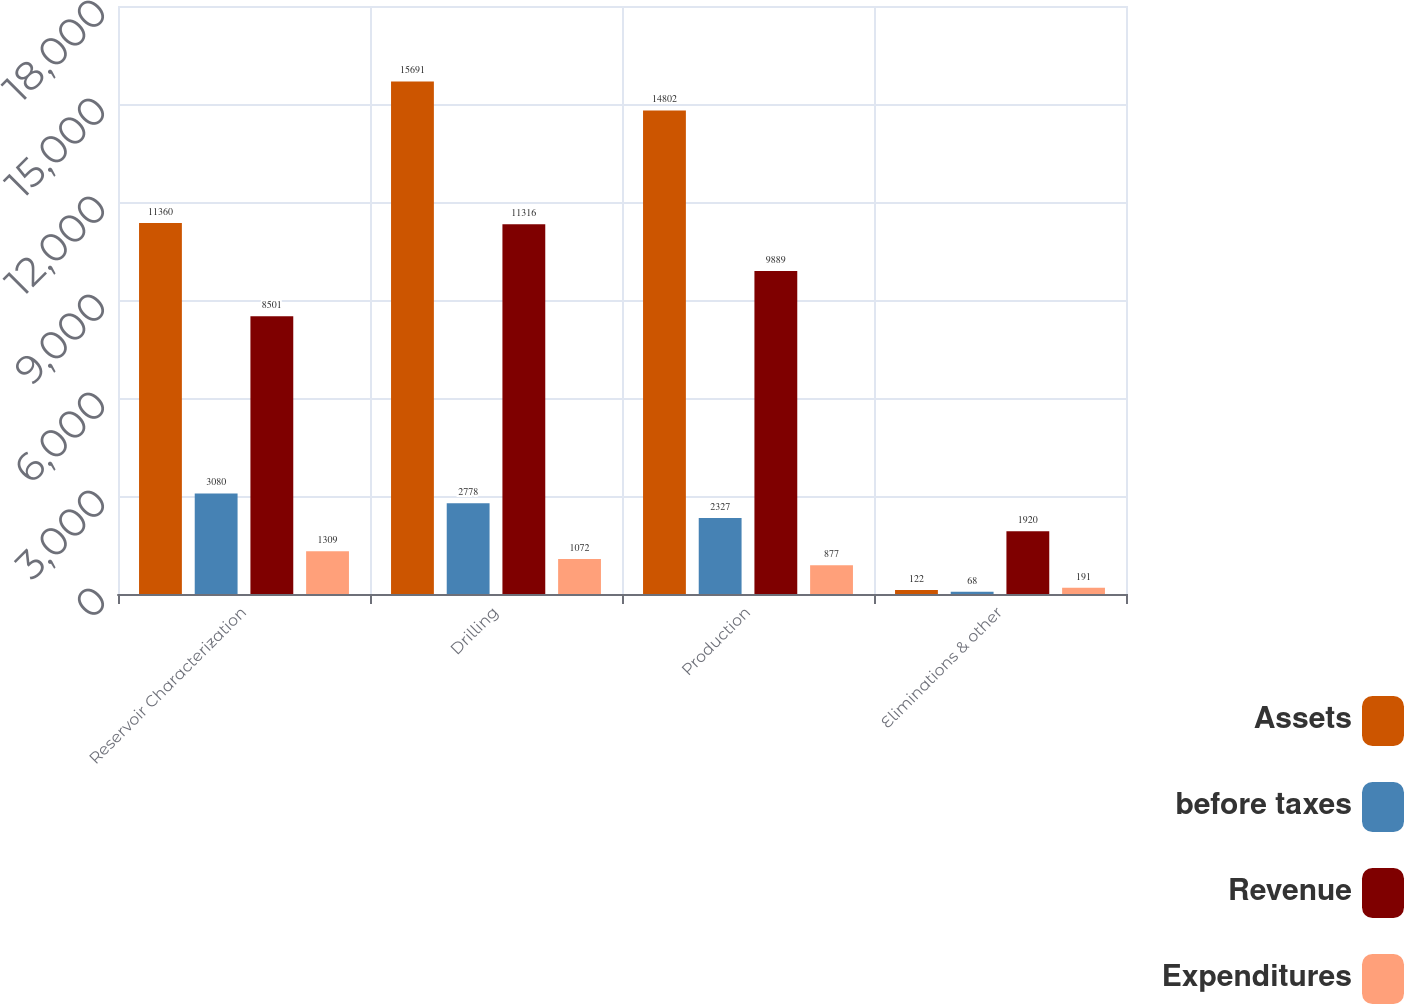Convert chart. <chart><loc_0><loc_0><loc_500><loc_500><stacked_bar_chart><ecel><fcel>Reservoir Characterization<fcel>Drilling<fcel>Production<fcel>Eliminations & other<nl><fcel>Assets<fcel>11360<fcel>15691<fcel>14802<fcel>122<nl><fcel>before taxes<fcel>3080<fcel>2778<fcel>2327<fcel>68<nl><fcel>Revenue<fcel>8501<fcel>11316<fcel>9889<fcel>1920<nl><fcel>Expenditures<fcel>1309<fcel>1072<fcel>877<fcel>191<nl></chart> 